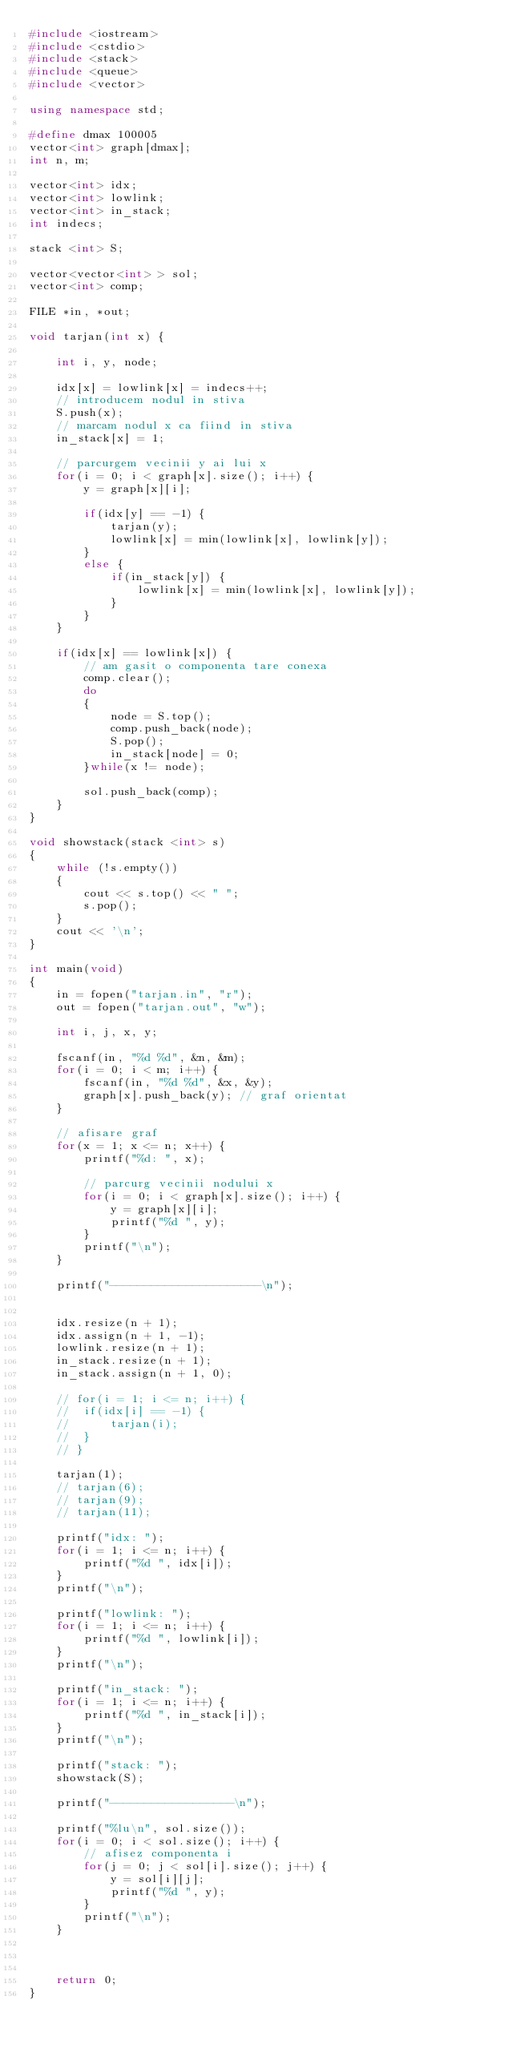Convert code to text. <code><loc_0><loc_0><loc_500><loc_500><_C++_>#include <iostream>
#include <cstdio>
#include <stack>
#include <queue>
#include <vector>

using namespace std;

#define dmax 100005
vector<int> graph[dmax];
int n, m;

vector<int> idx;
vector<int> lowlink;
vector<int> in_stack;
int indecs;

stack <int> S;

vector<vector<int> > sol;
vector<int> comp;

FILE *in, *out;

void tarjan(int x) {

	int i, y, node;

	idx[x] = lowlink[x] = indecs++;
	// introducem nodul in stiva
	S.push(x);
	// marcam nodul x ca fiind in stiva
	in_stack[x] = 1;

	// parcurgem vecinii y ai lui x
	for(i = 0; i < graph[x].size(); i++) {
		y = graph[x][i];

		if(idx[y] == -1) {
			tarjan(y);
			lowlink[x] = min(lowlink[x], lowlink[y]);
		}
		else {
			if(in_stack[y]) {
				lowlink[x] = min(lowlink[x], lowlink[y]);
			}
		}
	}

	if(idx[x] == lowlink[x]) {
		// am gasit o componenta tare conexa
		comp.clear();
		do
		{	
			node = S.top();
			comp.push_back(node);
			S.pop();
			in_stack[node] = 0;
		}while(x != node);

		sol.push_back(comp);
	}
}

void showstack(stack <int> s) 
{ 
    while (!s.empty()) 
    { 
        cout << s.top() << " "; 
        s.pop(); 
    } 
    cout << '\n'; 
} 

int main(void)
{
	in = fopen("tarjan.in", "r");
	out = fopen("tarjan.out", "w");

	int i, j, x, y;

	fscanf(in, "%d %d", &n, &m);
	for(i = 0; i < m; i++) {
		fscanf(in, "%d %d", &x, &y);
		graph[x].push_back(y); // graf orientat
	}

	// afisare graf
	for(x = 1; x <= n; x++) {
		printf("%d: ", x);

		// parcurg vecinii nodului x
		for(i = 0; i < graph[x].size(); i++) {
			y = graph[x][i];
			printf("%d ", y);
		}
		printf("\n");
	}

	printf("----------------------\n");


	idx.resize(n + 1); 
	idx.assign(n + 1, -1);
	lowlink.resize(n + 1);
	in_stack.resize(n + 1);
	in_stack.assign(n + 1, 0);

	// for(i = 1; i <= n; i++) {
	// 	if(idx[i] == -1) {
	// 		tarjan(i);
	// 	}
	// }

	tarjan(1);
	// tarjan(6);
	// tarjan(9);
	// tarjan(11);

	printf("idx: ");
	for(i = 1; i <= n; i++) {
		printf("%d ", idx[i]);
	}
	printf("\n");

	printf("lowlink: ");
	for(i = 1; i <= n; i++) {
		printf("%d ", lowlink[i]);
	}
	printf("\n");

	printf("in_stack: ");
	for(i = 1; i <= n; i++) {
		printf("%d ", in_stack[i]);
	}
	printf("\n");

	printf("stack: ");
	showstack(S);

	printf("------------------\n");

	printf("%lu\n", sol.size());
	for(i = 0; i < sol.size(); i++) {
		// afisez componenta i
		for(j = 0; j < sol[i].size(); j++) {
			y = sol[i][j];
			printf("%d ", y);
		}
		printf("\n");
	}



	return 0;
}</code> 